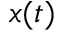Convert formula to latex. <formula><loc_0><loc_0><loc_500><loc_500>x ( t )</formula> 